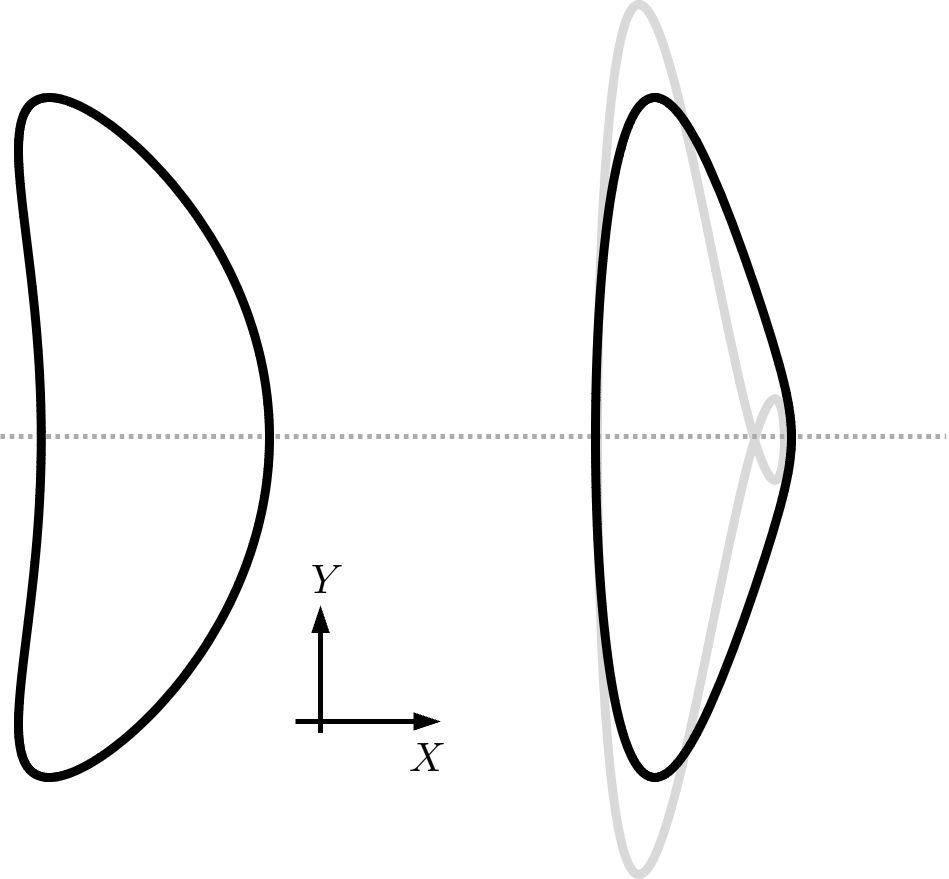Which geometric property is preserved in the transformation shown in the figure? A. Area B. Perimeter C. Angle measures D. Side ratios The transformation depicted in the image appears to be a dilation, where the shape is scaled up or down while maintaining the same proportions. In a dilation, the angles of the figure remain unchanged, and hence, the angle measures are preserved. The side ratios also change consistently, but they are scaled by the same factor. Therefore, the answer to the question would be C. Angle measures, as this property is explicitly preserved in all dilations. 